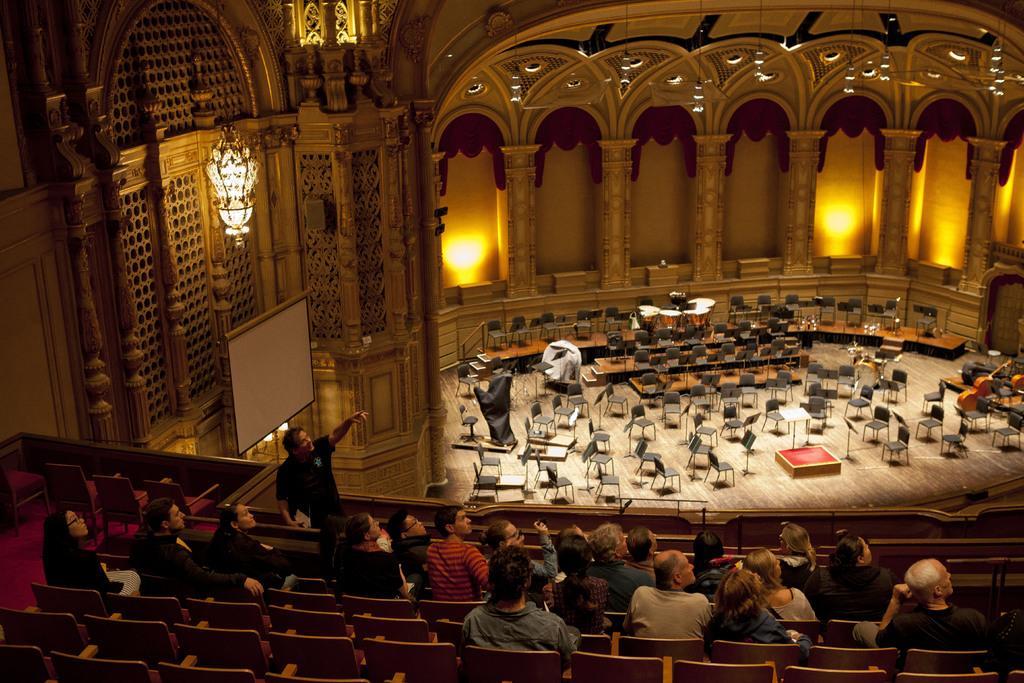In one or two sentences, can you explain what this image depicts? In this image I can see few persons sitting on benches which are brown in color and a person wearing black dress is standing in front of them and in the background I can see the interior of the building, a chandelier, few lights, aboard, few chairs and a musical instrument. 